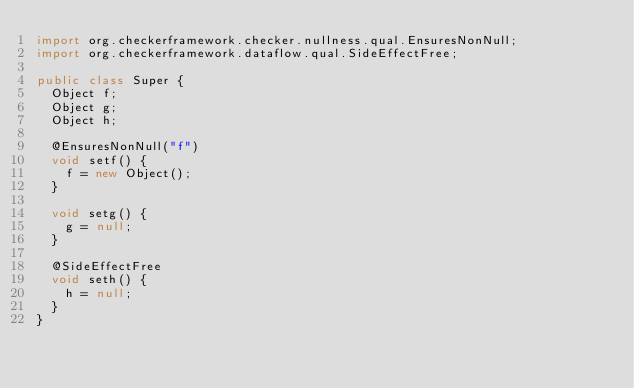Convert code to text. <code><loc_0><loc_0><loc_500><loc_500><_Java_>import org.checkerframework.checker.nullness.qual.EnsuresNonNull;
import org.checkerframework.dataflow.qual.SideEffectFree;

public class Super {
  Object f;
  Object g;
  Object h;

  @EnsuresNonNull("f")
  void setf() {
    f = new Object();
  }

  void setg() {
    g = null;
  }

  @SideEffectFree
  void seth() {
    h = null;
  }
}
</code> 